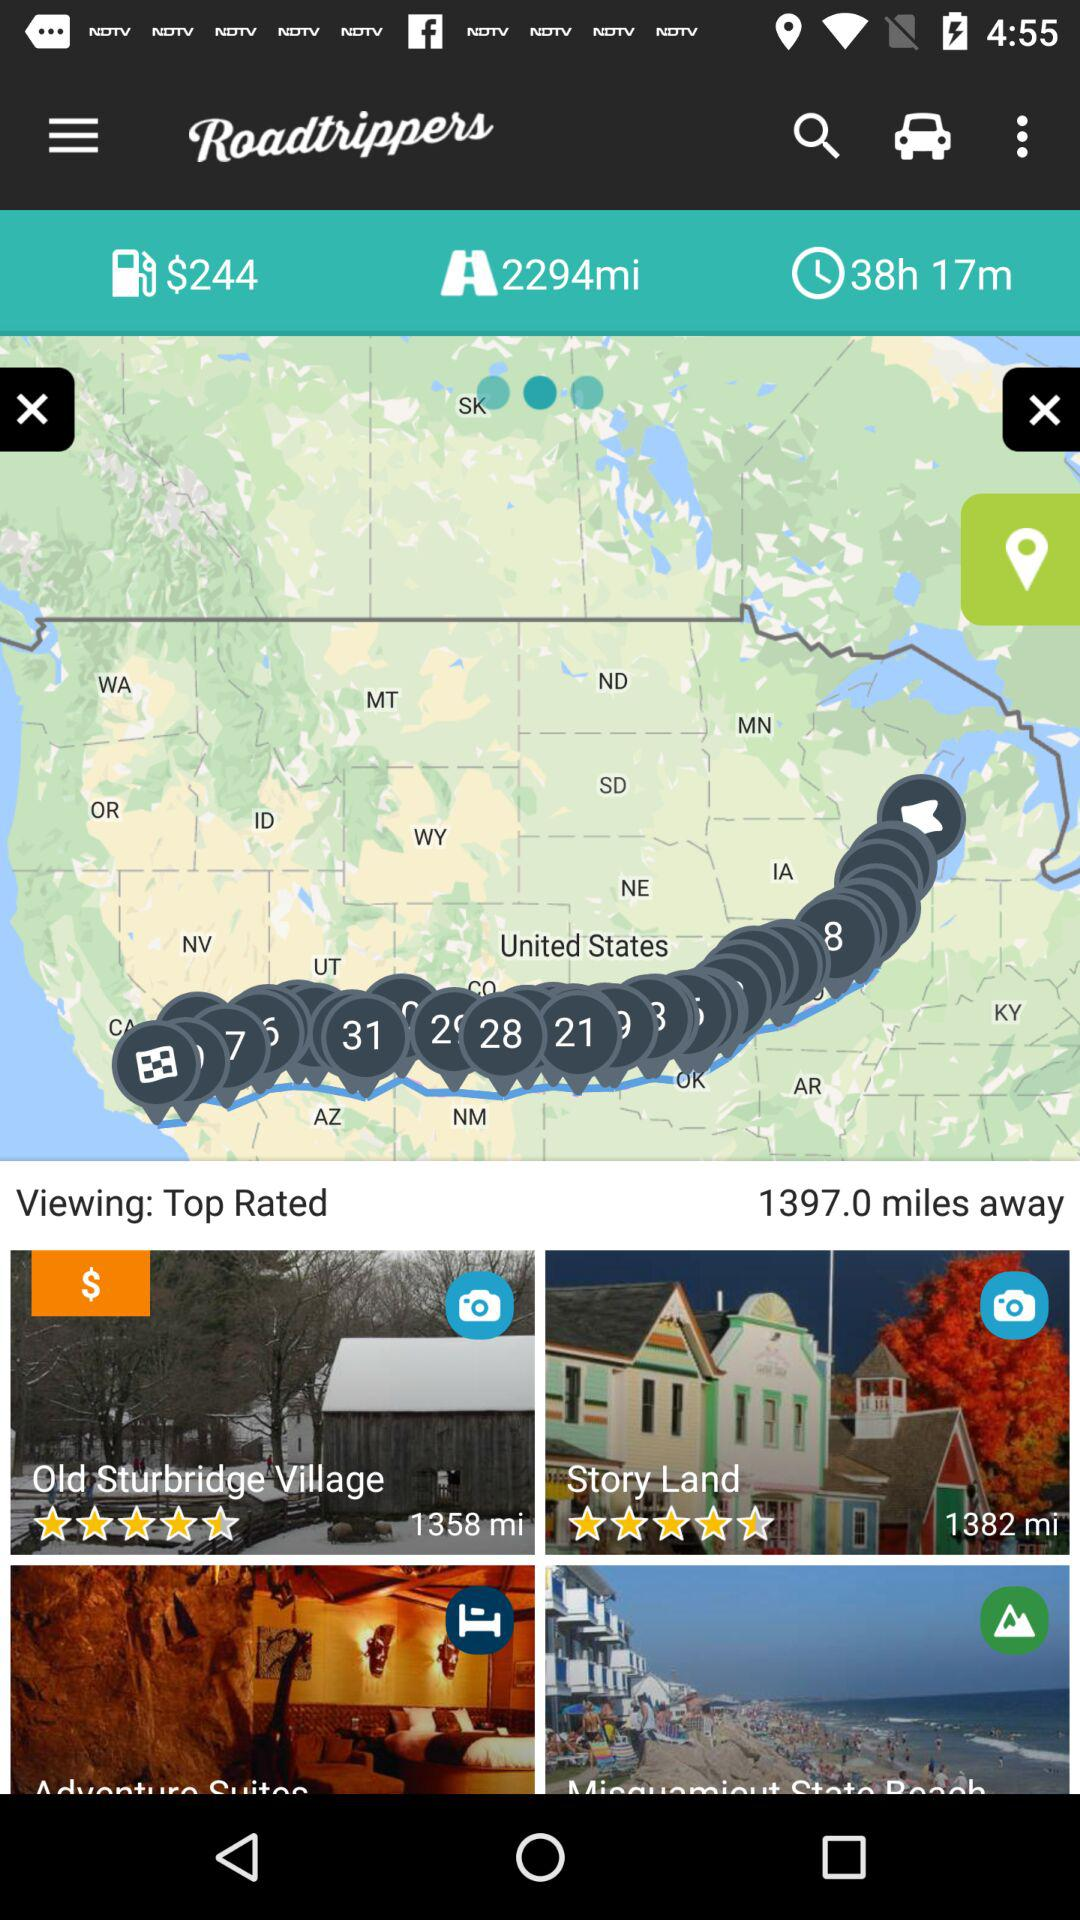How many miles away is "Story Land"? "Story Land" is 1382 miles away. 